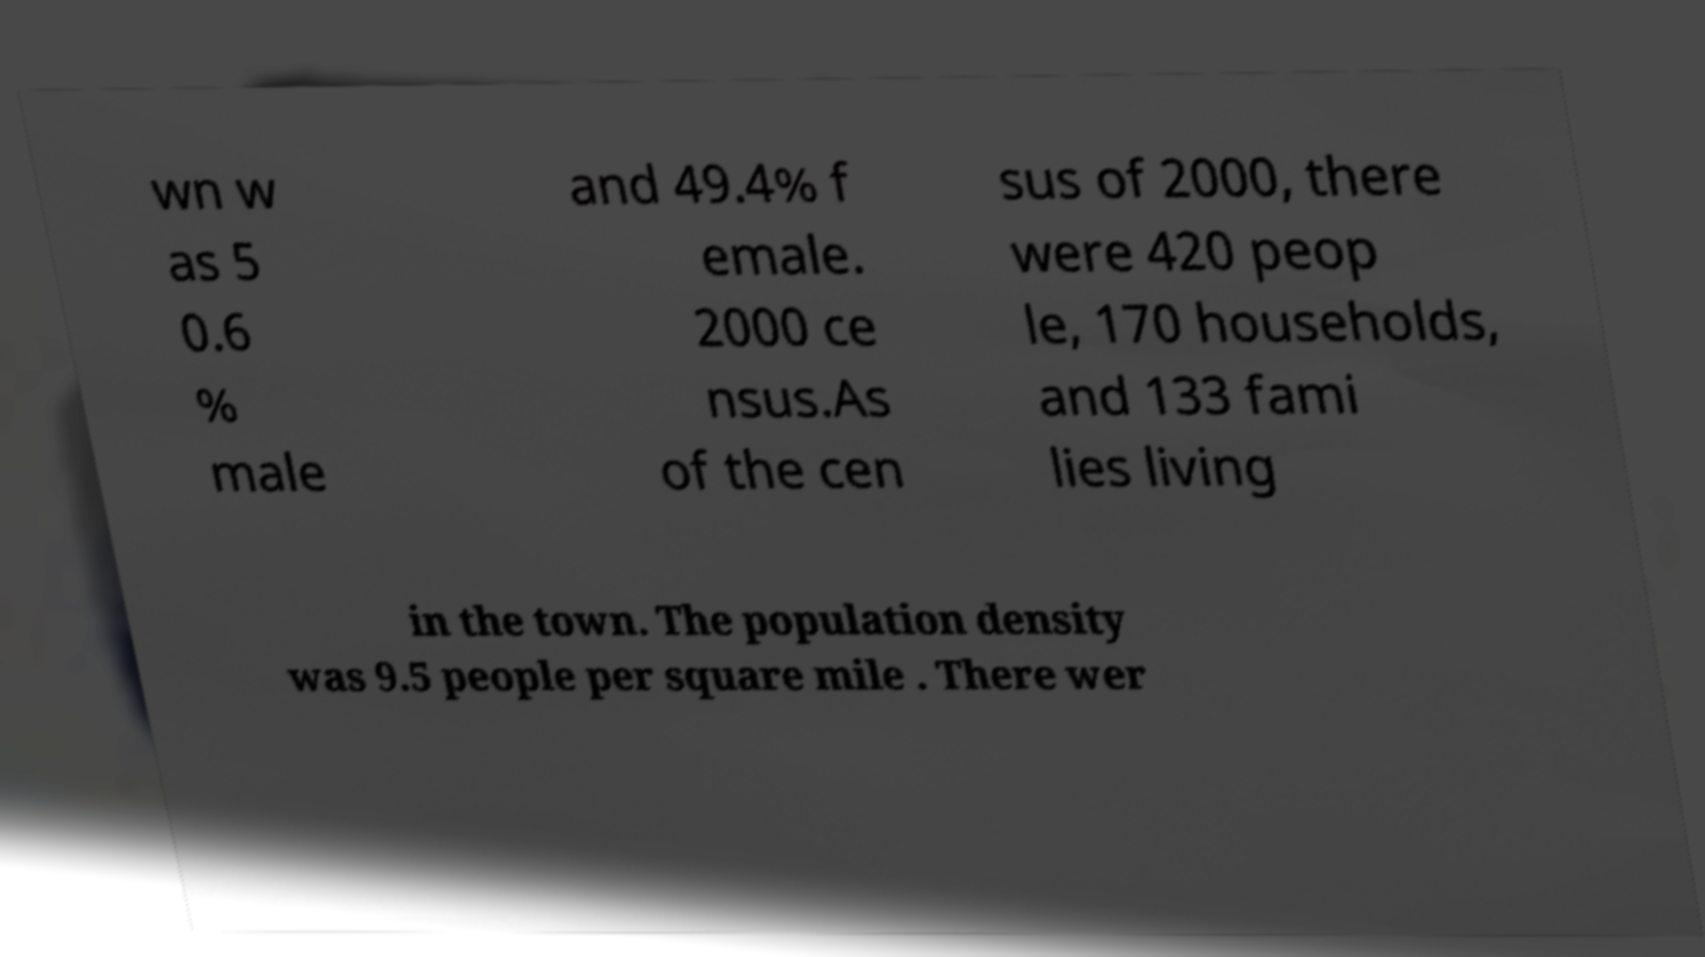Please identify and transcribe the text found in this image. wn w as 5 0.6 % male and 49.4% f emale. 2000 ce nsus.As of the cen sus of 2000, there were 420 peop le, 170 households, and 133 fami lies living in the town. The population density was 9.5 people per square mile . There wer 